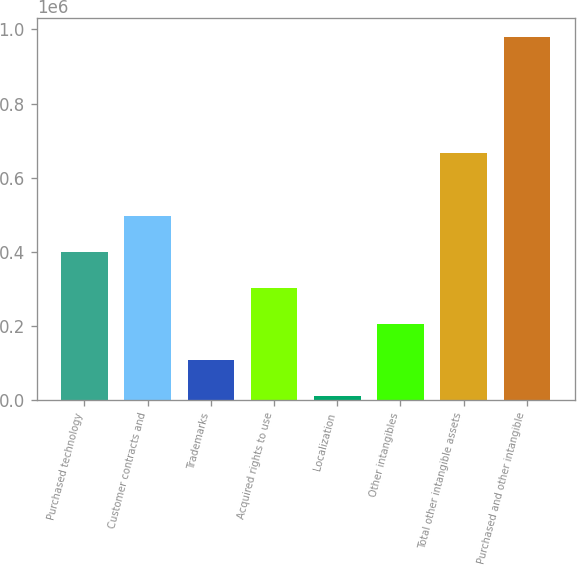Convert chart. <chart><loc_0><loc_0><loc_500><loc_500><bar_chart><fcel>Purchased technology<fcel>Customer contracts and<fcel>Trademarks<fcel>Acquired rights to use<fcel>Localization<fcel>Other intangibles<fcel>Total other intangible assets<fcel>Purchased and other intangible<nl><fcel>398200<fcel>495310<fcel>106872<fcel>301091<fcel>9762<fcel>203981<fcel>666801<fcel>980858<nl></chart> 